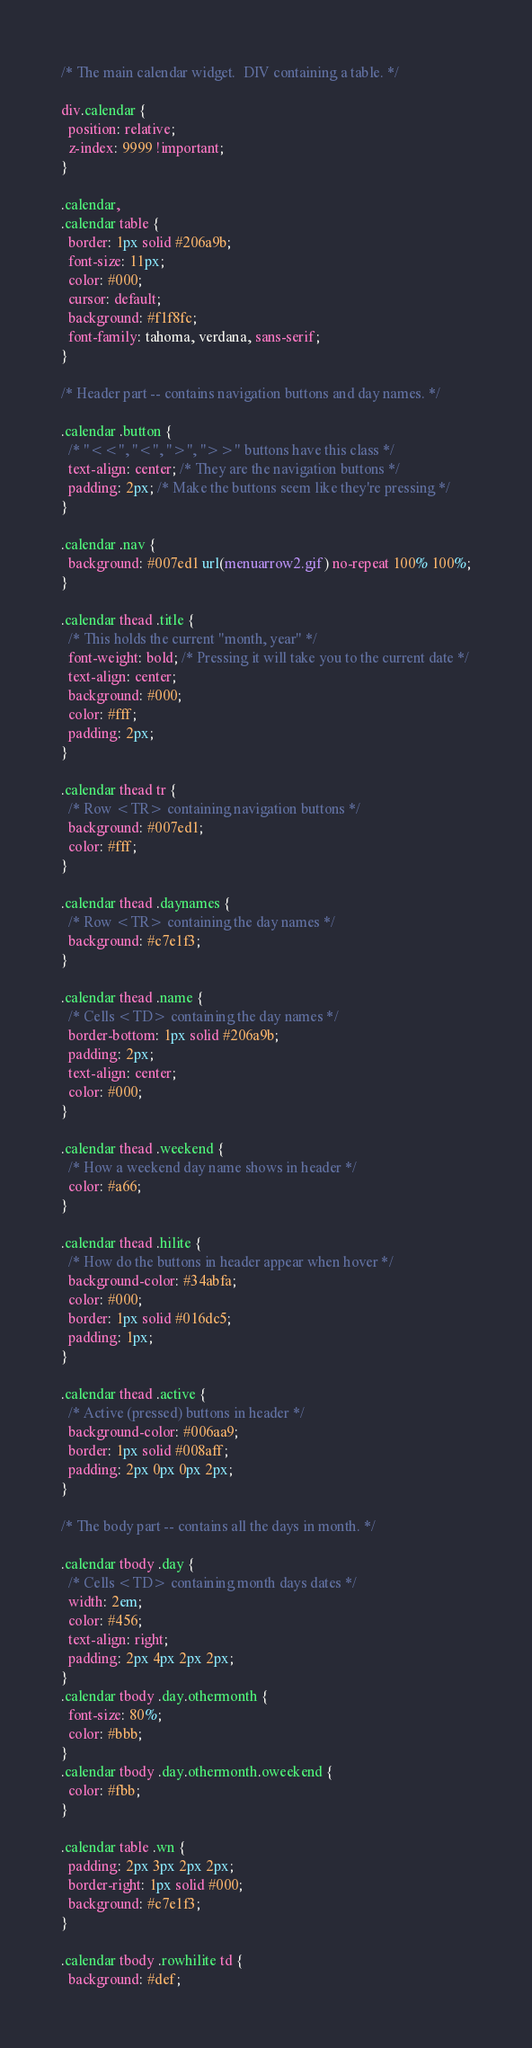Convert code to text. <code><loc_0><loc_0><loc_500><loc_500><_CSS_>/* The main calendar widget.  DIV containing a table. */

div.calendar {
  position: relative;
  z-index: 9999 !important;
}

.calendar,
.calendar table {
  border: 1px solid #206a9b;
  font-size: 11px;
  color: #000;
  cursor: default;
  background: #f1f8fc;
  font-family: tahoma, verdana, sans-serif;
}

/* Header part -- contains navigation buttons and day names. */

.calendar .button {
  /* "<<", "<", ">", ">>" buttons have this class */
  text-align: center; /* They are the navigation buttons */
  padding: 2px; /* Make the buttons seem like they're pressing */
}

.calendar .nav {
  background: #007ed1 url(menuarrow2.gif) no-repeat 100% 100%;
}

.calendar thead .title {
  /* This holds the current "month, year" */
  font-weight: bold; /* Pressing it will take you to the current date */
  text-align: center;
  background: #000;
  color: #fff;
  padding: 2px;
}

.calendar thead tr {
  /* Row <TR> containing navigation buttons */
  background: #007ed1;
  color: #fff;
}

.calendar thead .daynames {
  /* Row <TR> containing the day names */
  background: #c7e1f3;
}

.calendar thead .name {
  /* Cells <TD> containing the day names */
  border-bottom: 1px solid #206a9b;
  padding: 2px;
  text-align: center;
  color: #000;
}

.calendar thead .weekend {
  /* How a weekend day name shows in header */
  color: #a66;
}

.calendar thead .hilite {
  /* How do the buttons in header appear when hover */
  background-color: #34abfa;
  color: #000;
  border: 1px solid #016dc5;
  padding: 1px;
}

.calendar thead .active {
  /* Active (pressed) buttons in header */
  background-color: #006aa9;
  border: 1px solid #008aff;
  padding: 2px 0px 0px 2px;
}

/* The body part -- contains all the days in month. */

.calendar tbody .day {
  /* Cells <TD> containing month days dates */
  width: 2em;
  color: #456;
  text-align: right;
  padding: 2px 4px 2px 2px;
}
.calendar tbody .day.othermonth {
  font-size: 80%;
  color: #bbb;
}
.calendar tbody .day.othermonth.oweekend {
  color: #fbb;
}

.calendar table .wn {
  padding: 2px 3px 2px 2px;
  border-right: 1px solid #000;
  background: #c7e1f3;
}

.calendar tbody .rowhilite td {
  background: #def;</code> 